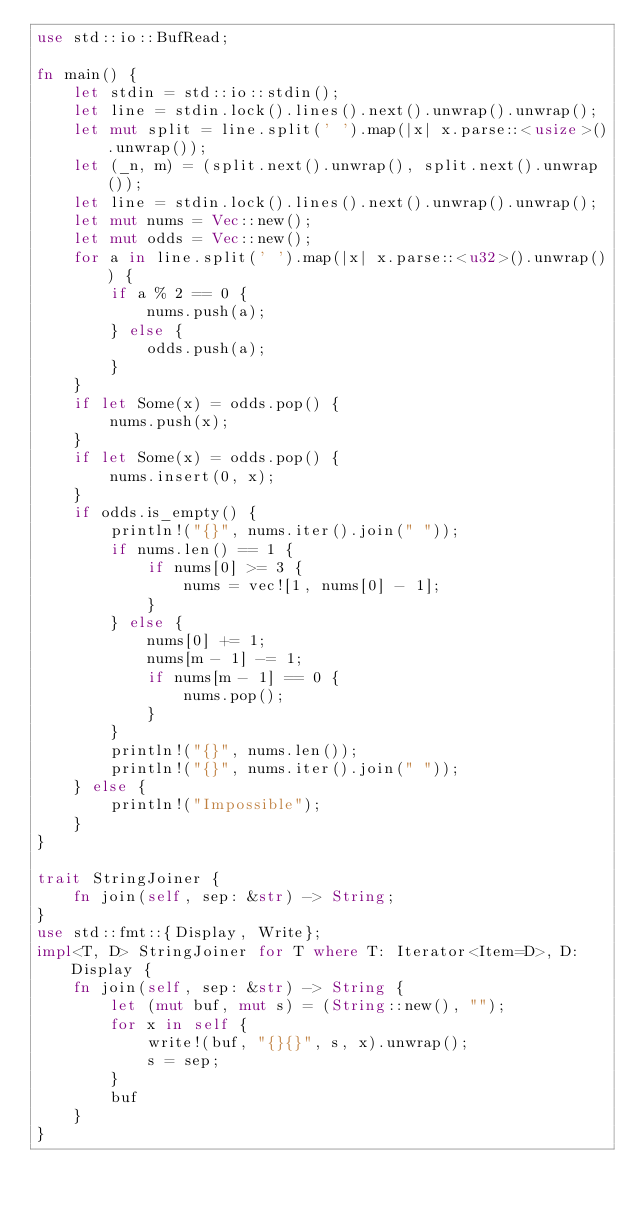<code> <loc_0><loc_0><loc_500><loc_500><_Rust_>use std::io::BufRead;

fn main() {
    let stdin = std::io::stdin();
    let line = stdin.lock().lines().next().unwrap().unwrap();
    let mut split = line.split(' ').map(|x| x.parse::<usize>().unwrap());
    let (_n, m) = (split.next().unwrap(), split.next().unwrap());
    let line = stdin.lock().lines().next().unwrap().unwrap();
    let mut nums = Vec::new();
    let mut odds = Vec::new();
    for a in line.split(' ').map(|x| x.parse::<u32>().unwrap()) {
        if a % 2 == 0 {
            nums.push(a);
        } else {
            odds.push(a);
        }
    }
    if let Some(x) = odds.pop() {
        nums.push(x);
    }
    if let Some(x) = odds.pop() {
        nums.insert(0, x);
    }
    if odds.is_empty() {
        println!("{}", nums.iter().join(" "));
        if nums.len() == 1 {
            if nums[0] >= 3 {
                nums = vec![1, nums[0] - 1];
            }
        } else {
            nums[0] += 1;
            nums[m - 1] -= 1;
            if nums[m - 1] == 0 {
                nums.pop();
            }
        }
        println!("{}", nums.len());
        println!("{}", nums.iter().join(" "));
    } else {
        println!("Impossible");
    }
}

trait StringJoiner {
    fn join(self, sep: &str) -> String;
}
use std::fmt::{Display, Write};
impl<T, D> StringJoiner for T where T: Iterator<Item=D>, D: Display {
    fn join(self, sep: &str) -> String {
        let (mut buf, mut s) = (String::new(), "");
        for x in self {
            write!(buf, "{}{}", s, x).unwrap();
            s = sep;
        }
        buf
    }
}
</code> 